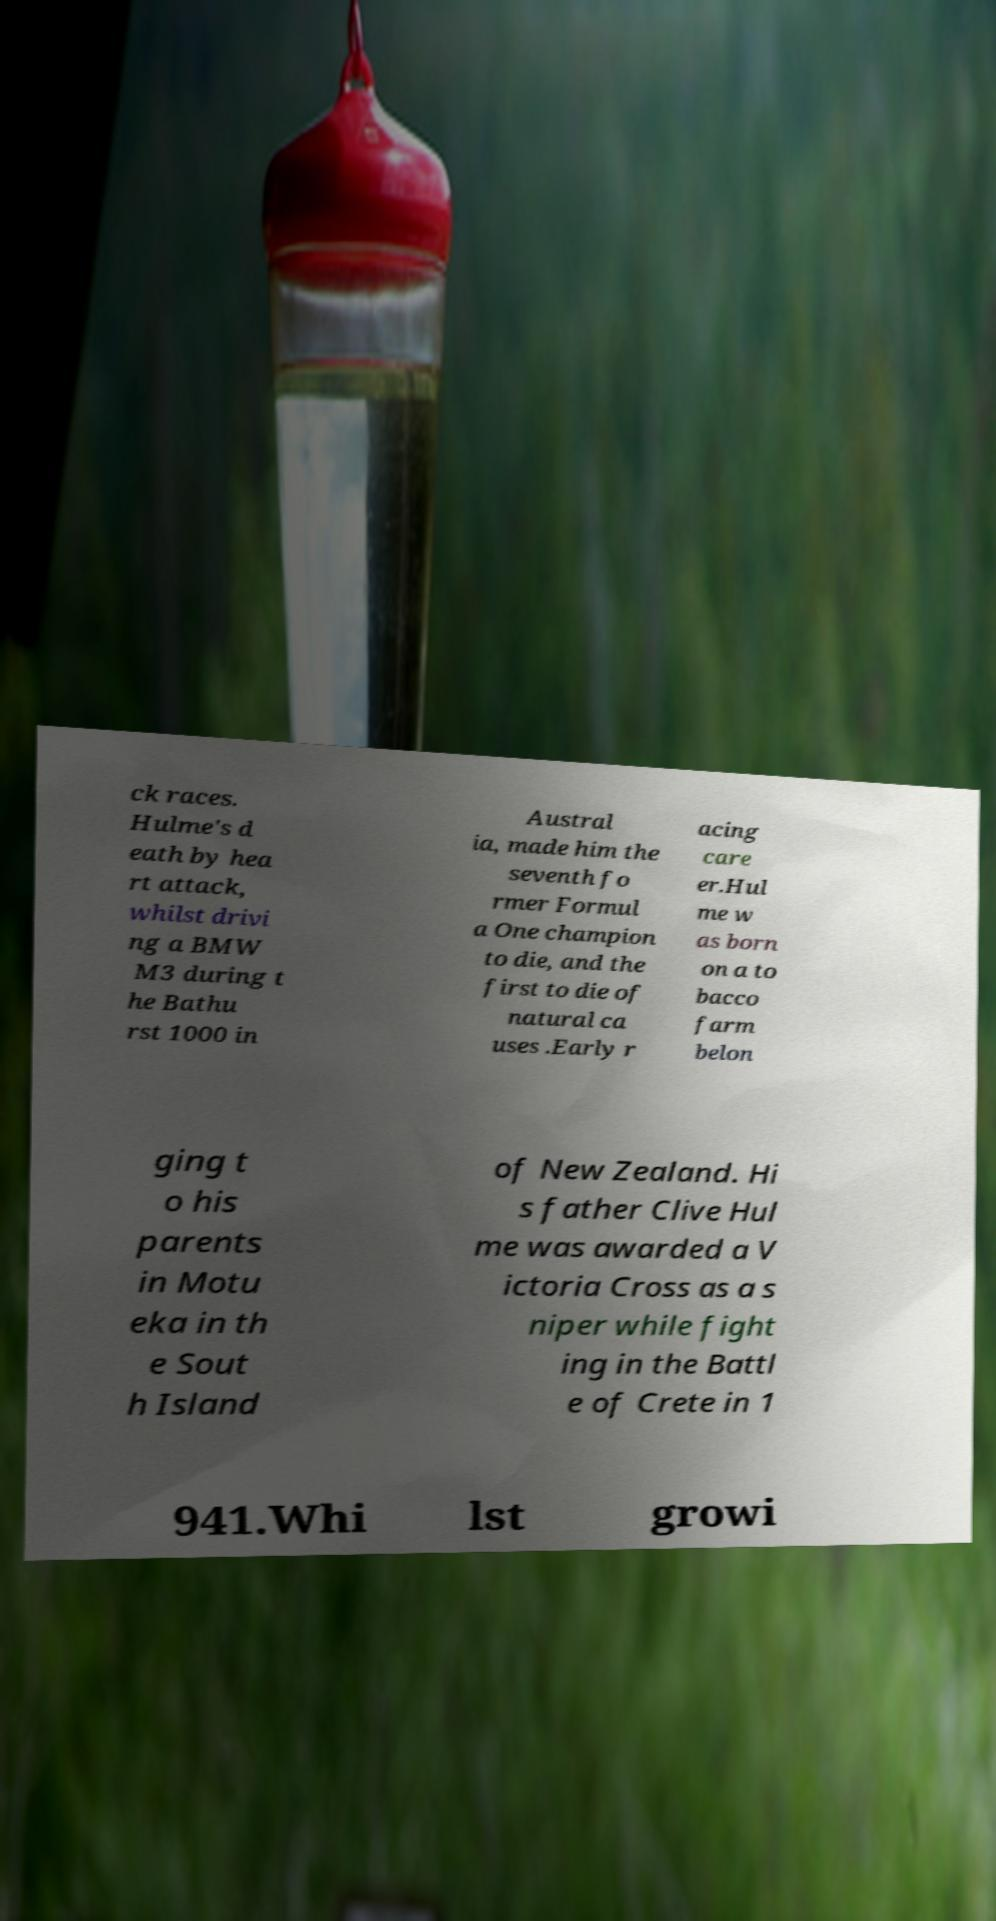There's text embedded in this image that I need extracted. Can you transcribe it verbatim? ck races. Hulme's d eath by hea rt attack, whilst drivi ng a BMW M3 during t he Bathu rst 1000 in Austral ia, made him the seventh fo rmer Formul a One champion to die, and the first to die of natural ca uses .Early r acing care er.Hul me w as born on a to bacco farm belon ging t o his parents in Motu eka in th e Sout h Island of New Zealand. Hi s father Clive Hul me was awarded a V ictoria Cross as a s niper while fight ing in the Battl e of Crete in 1 941.Whi lst growi 